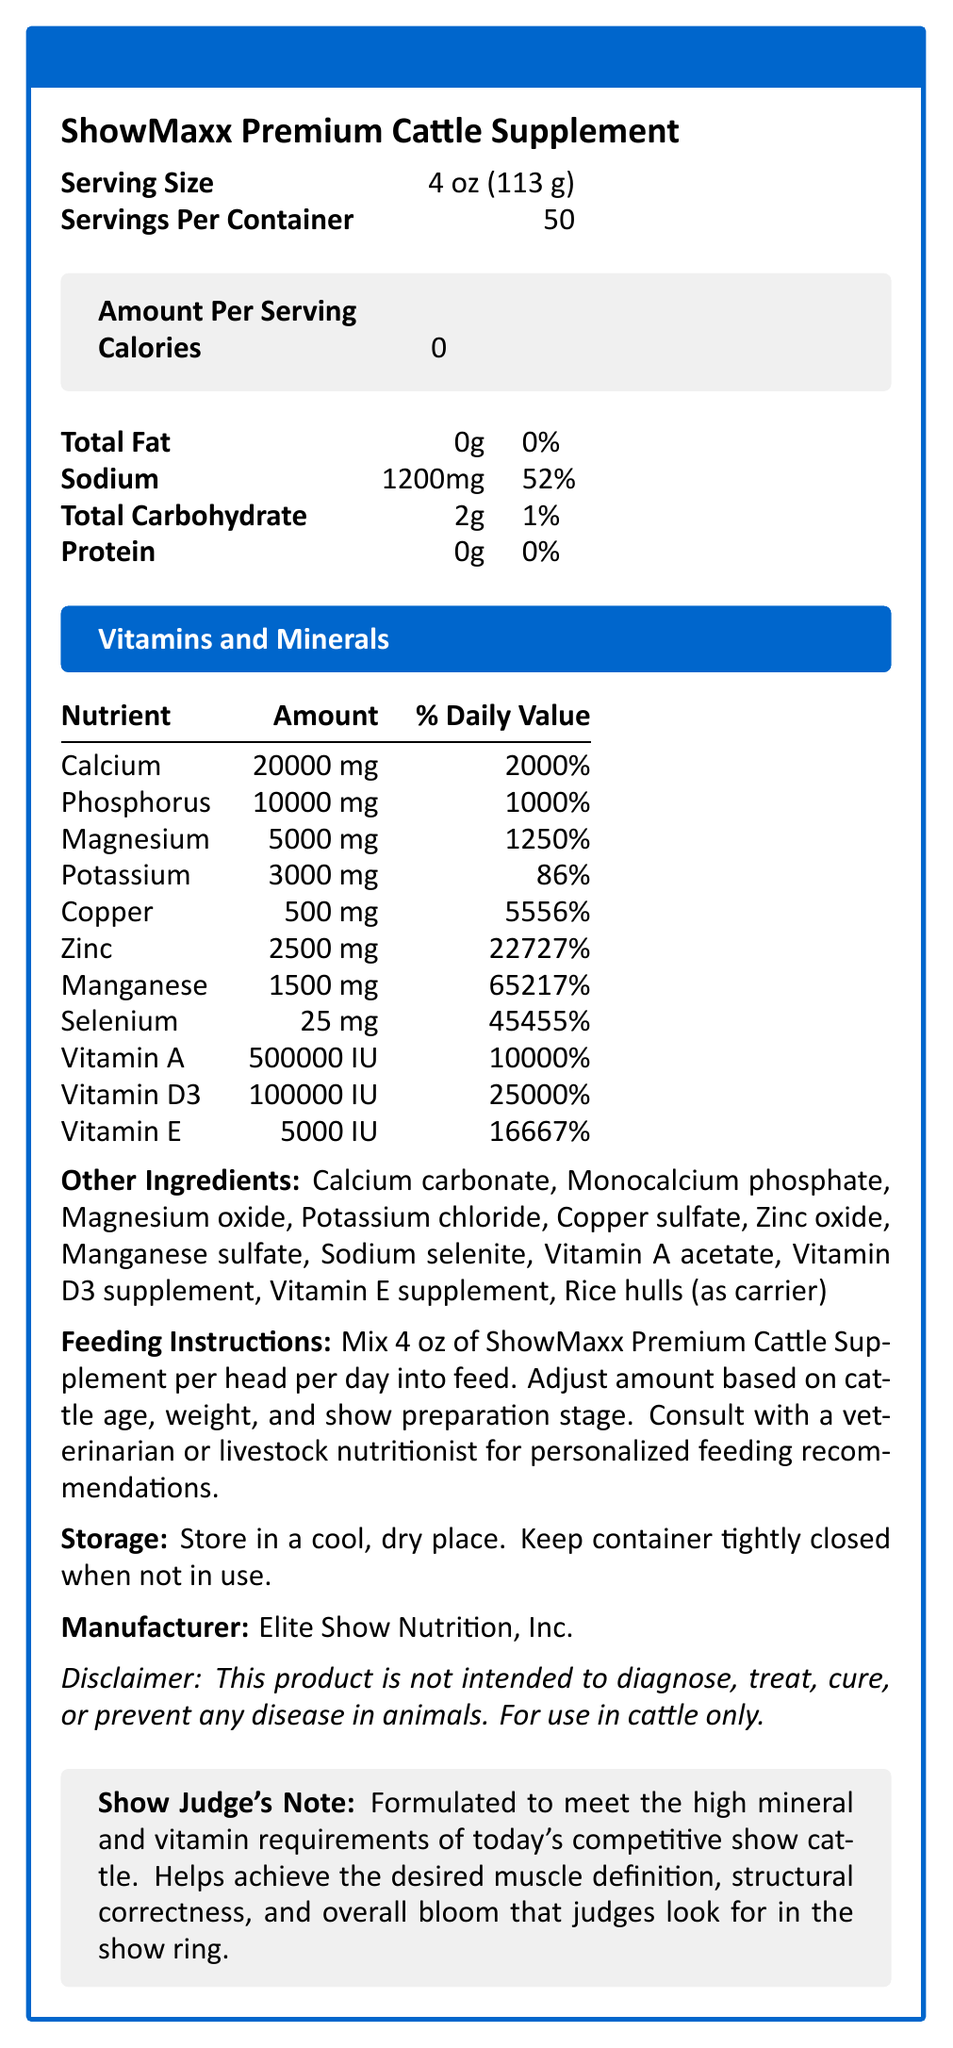what is the serving size of ShowMaxx Premium Cattle Supplement? The serving size is listed as 4 oz (113 g) in the document.
Answer: 4 oz (113 g) how much sodium is in one serving of the supplement? The document states that the amount of sodium in one serving is 1200 mg.
Answer: 1200 mg how many servings are there per container of ShowMaxx Premium Cattle Supplement? The document indicates that there are 50 servings per container.
Answer: 50 what is the percentage of daily value for calcium in one serving of the supplement? One serving contains 20,000 mg of calcium, which is 2000% of the daily value.
Answer: 2000% list two key benefits of the ShowMaxx Premium Cattle Supplement. The document lists several key benefits, including promoting optimal bone and muscle development and enhancing coat shine and overall appearance.
Answer: Promotes optimal bone and muscle development, Enhances coat shine and overall appearance what should you do with the container when not in use? The document advises keeping the container tightly closed when not in use.
Answer: Keep container tightly closed who manufactures the ShowMaxx Premium Cattle Supplement? The manufacturer is listed as Elite Show Nutrition, Inc.
Answer: Elite Show Nutrition, Inc. Name one of the vitamins included in this supplement. The document lists Vitamin A as one of the included vitamins.
Answer: Vitamin A what is the main focus of the Show Judge's Note section? The Show Judge's Note states that the supplement helps achieve the desired muscle definition, structural correctness, and overall bloom that judges look for in the show ring.
Answer: Helping achieve muscle definition, structural correctness, and overall bloom which vitamin comes in the highest percentage of daily value? A. Vitamin A B. Vitamin D3 C. Vitamin E According to the document, Vitamin D3 has a daily value of 25000%, which is the highest among the listed vitamins.
Answer: B. Vitamin D3 how much phosphorus is in one serving of the supplement? A. 1000 mg B. 5000 mg C. 10000 mg D. 15000 mg The document clearly lists 10000 mg for phosphorus in one serving.
Answer: C. 10000 mg Does the ShowMaxx Premium Cattle Supplement contain any carbohydrates? The document lists a total carbohydrate content of 2 g per serving.
Answer: Yes Is this product intended for use in animals other than cattle? The document specifically mentions that the product is for use in cattle only.
Answer: No summarize the main idea of this document. The main idea of this document is to present comprehensive nutritional information about the ShowMaxx Premium Cattle Supplement, its key benefits, usage guidelines, and its alignment with the high standards required in competitive cattle showing.
Answer: The document provides detailed nutritional information for ShowMaxx Premium Cattle Supplement, including serving size, vitamins and minerals content, feeding and storage instructions, manufacturer details, benefits, and a Show Judge's Note emphasizing its impact on show cattle. What specific advice does the document give regarding feeding adjustments? The document mentions adjusting amounts based on cattle age, weight, and show preparation stage and advises consulting with a veterinarian or livestock nutritionist, but it does not provide specific amounts or guidelines for adjustments.
Answer: Not enough information 